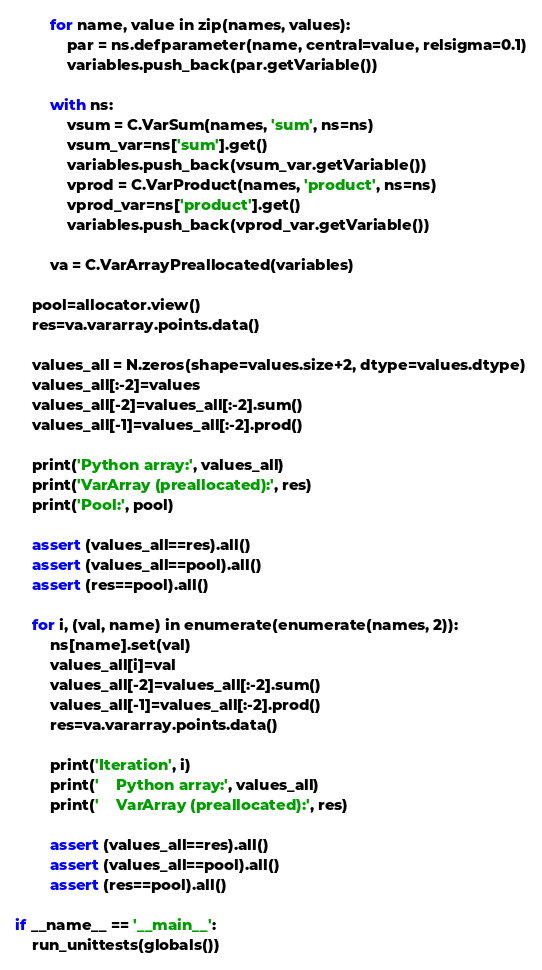Convert code to text. <code><loc_0><loc_0><loc_500><loc_500><_Python_>        for name, value in zip(names, values):
            par = ns.defparameter(name, central=value, relsigma=0.1)
            variables.push_back(par.getVariable())

        with ns:
            vsum = C.VarSum(names, 'sum', ns=ns)
            vsum_var=ns['sum'].get()
            variables.push_back(vsum_var.getVariable())
            vprod = C.VarProduct(names, 'product', ns=ns)
            vprod_var=ns['product'].get()
            variables.push_back(vprod_var.getVariable())

        va = C.VarArrayPreallocated(variables)

    pool=allocator.view()
    res=va.vararray.points.data()

    values_all = N.zeros(shape=values.size+2, dtype=values.dtype)
    values_all[:-2]=values
    values_all[-2]=values_all[:-2].sum()
    values_all[-1]=values_all[:-2].prod()

    print('Python array:', values_all)
    print('VarArray (preallocated):', res)
    print('Pool:', pool)

    assert (values_all==res).all()
    assert (values_all==pool).all()
    assert (res==pool).all()

    for i, (val, name) in enumerate(enumerate(names, 2)):
        ns[name].set(val)
        values_all[i]=val
        values_all[-2]=values_all[:-2].sum()
        values_all[-1]=values_all[:-2].prod()
        res=va.vararray.points.data()

        print('Iteration', i)
        print('    Python array:', values_all)
        print('    VarArray (preallocated):', res)

        assert (values_all==res).all()
        assert (values_all==pool).all()
        assert (res==pool).all()

if __name__ == '__main__':
    run_unittests(globals())
</code> 